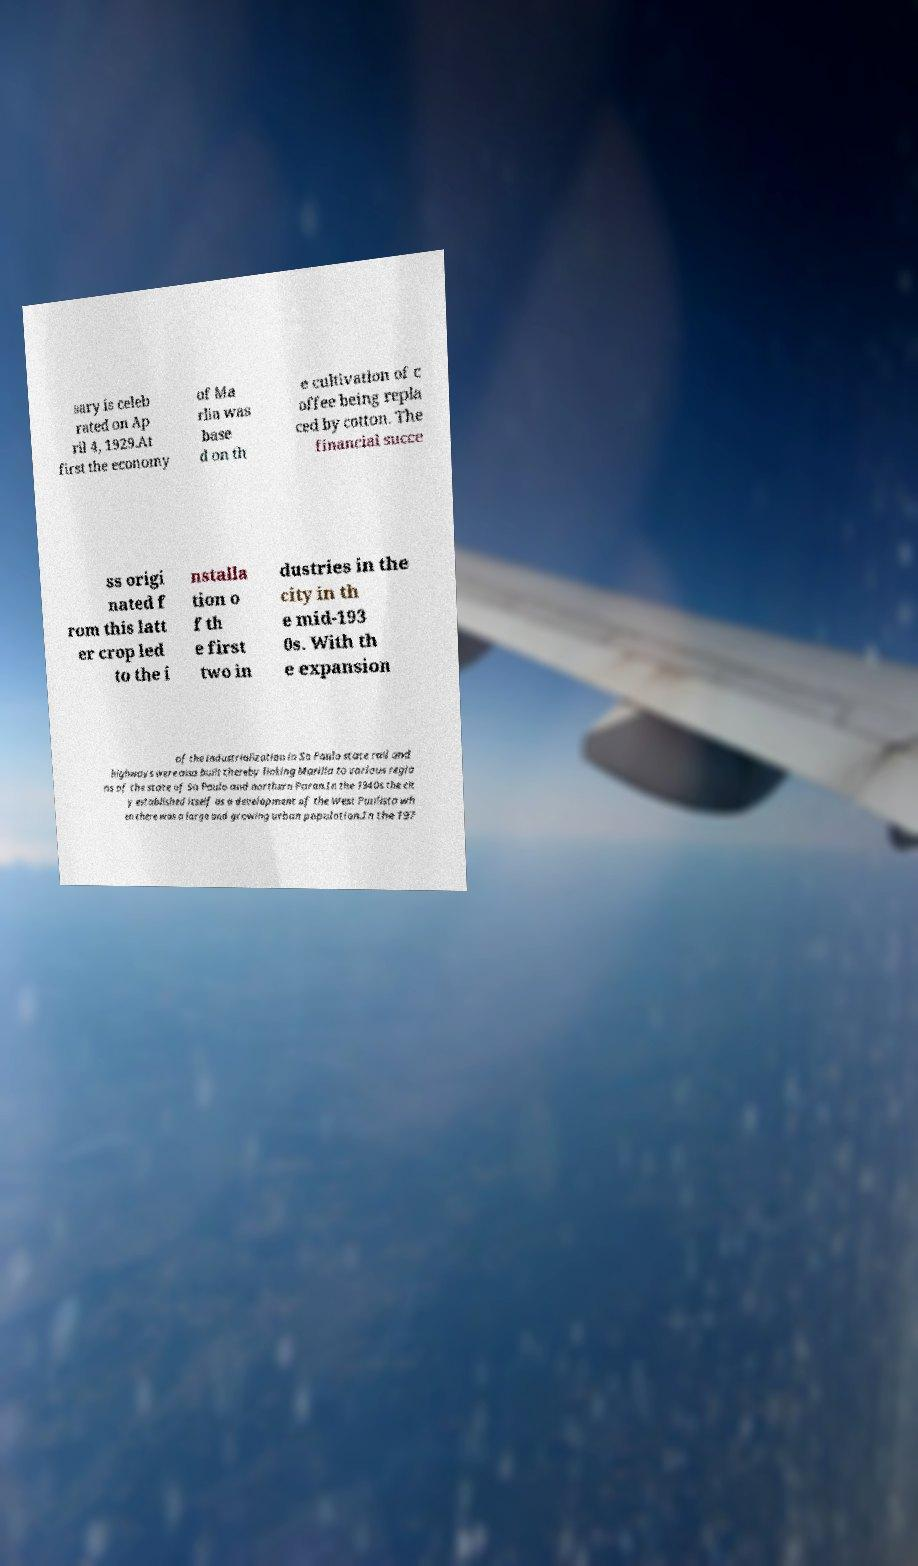Can you accurately transcribe the text from the provided image for me? sary is celeb rated on Ap ril 4, 1929.At first the economy of Ma rlia was base d on th e cultivation of c offee being repla ced by cotton. The financial succe ss origi nated f rom this latt er crop led to the i nstalla tion o f th e first two in dustries in the city in th e mid-193 0s. With th e expansion of the industrialization in So Paulo state rail and highways were also built thereby linking Marilia to various regio ns of the state of So Paulo and northern Paran.In the 1940s the cit y established itself as a development of the West Paulista wh en there was a large and growing urban population.In the 197 